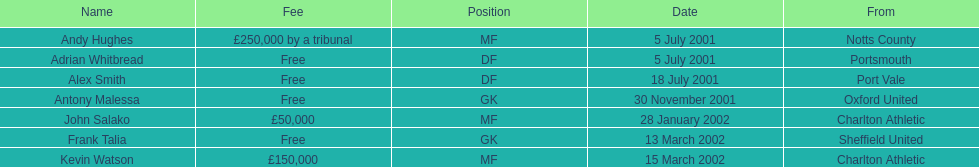What are the names of all the players? Andy Hughes, Adrian Whitbread, Alex Smith, Antony Malessa, John Salako, Frank Talia, Kevin Watson. What fee did andy hughes command? £250,000 by a tribunal. What fee did john salako command? £50,000. Which player had the highest fee, andy hughes or john salako? Andy Hughes. 